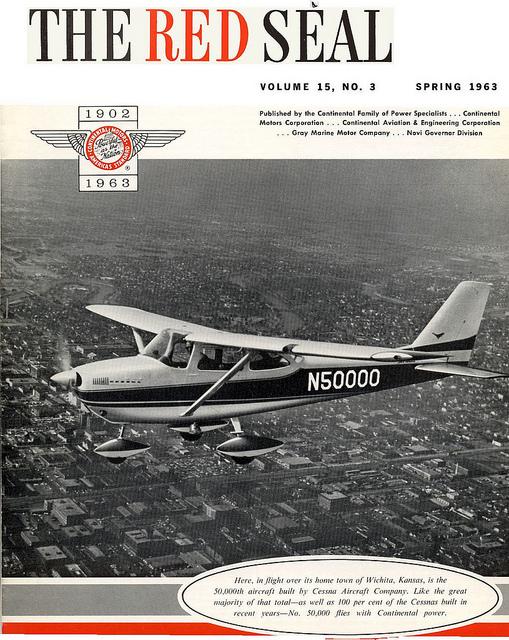What volume is this from?
Concise answer only. 15. What is the plane called?
Quick response, please. Red seal. What year is this magazine from?
Write a very short answer. 1963. 